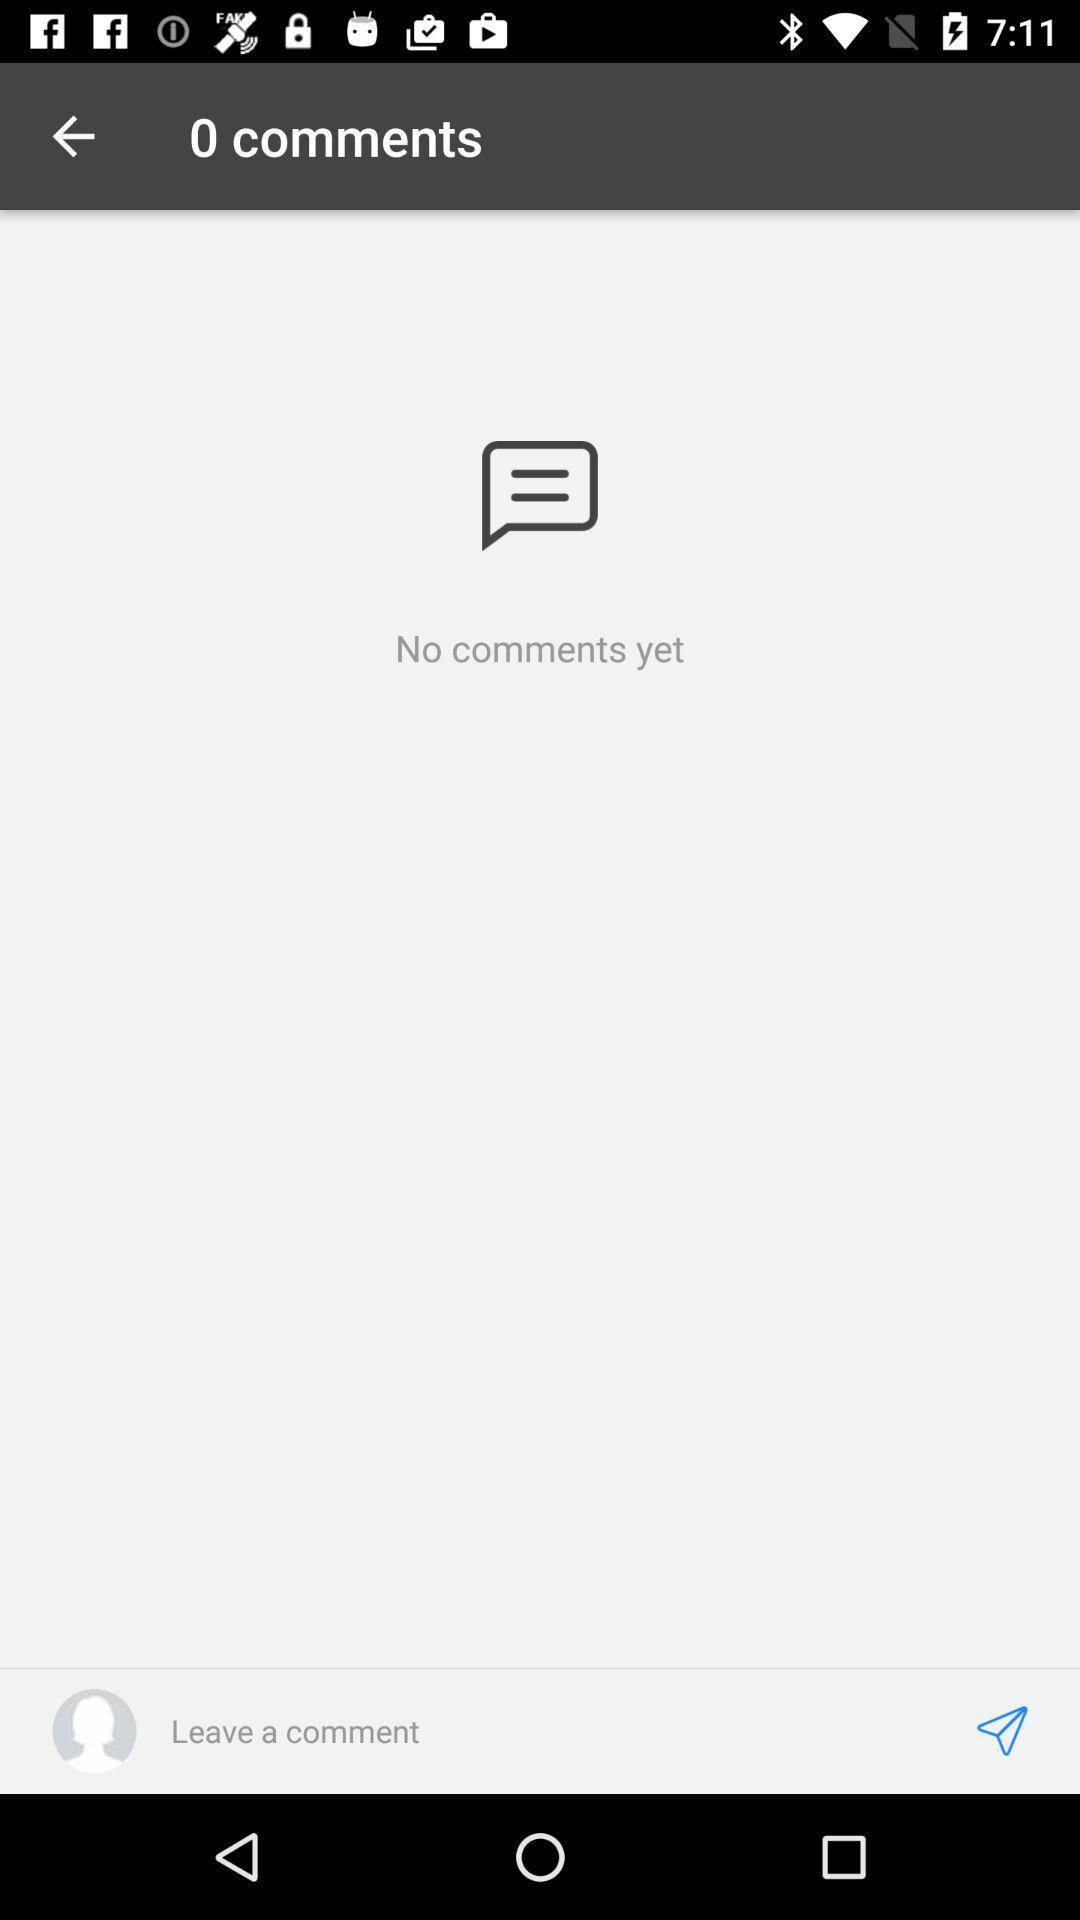How many comments are there on this post?
Answer the question using a single word or phrase. 0 